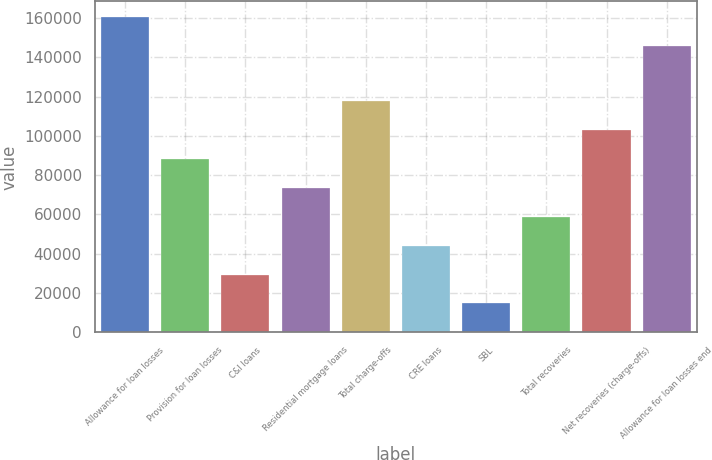<chart> <loc_0><loc_0><loc_500><loc_500><bar_chart><fcel>Allowance for loan losses<fcel>Provision for loan losses<fcel>C&I loans<fcel>Residential mortgage loans<fcel>Total charge-offs<fcel>CRE loans<fcel>SBL<fcel>Total recoveries<fcel>Net recoveries (charge-offs)<fcel>Allowance for loan losses end<nl><fcel>160452<fcel>88251.3<fcel>29418.5<fcel>73543.1<fcel>117668<fcel>44126.7<fcel>14710.4<fcel>58834.9<fcel>102959<fcel>145744<nl></chart> 